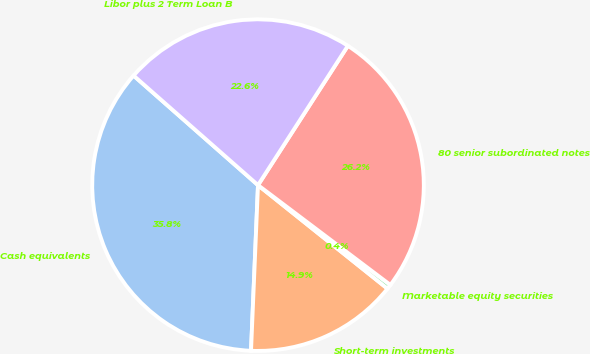Convert chart. <chart><loc_0><loc_0><loc_500><loc_500><pie_chart><fcel>Cash equivalents<fcel>Short-term investments<fcel>Marketable equity securities<fcel>80 senior subordinated notes<fcel>Libor plus 2 Term Loan B<nl><fcel>35.82%<fcel>14.94%<fcel>0.45%<fcel>26.17%<fcel>22.63%<nl></chart> 